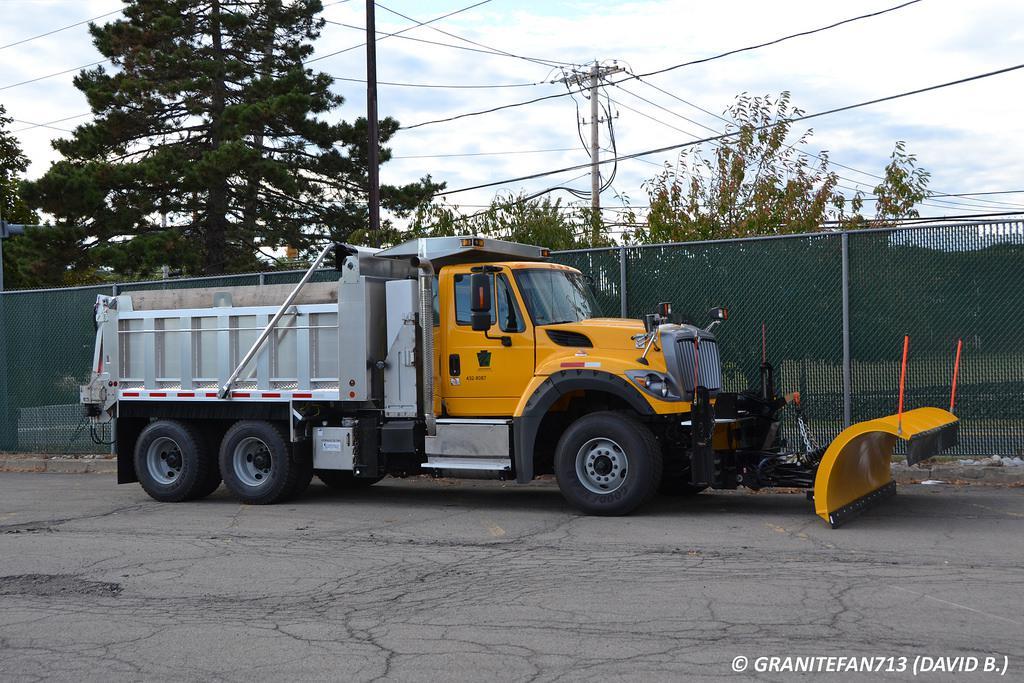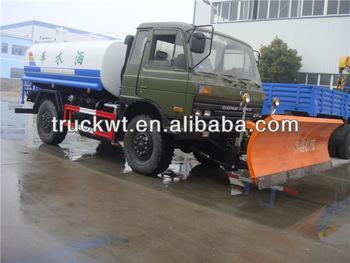The first image is the image on the left, the second image is the image on the right. Considering the images on both sides, is "All trucks have attached shovels." valid? Answer yes or no. Yes. 